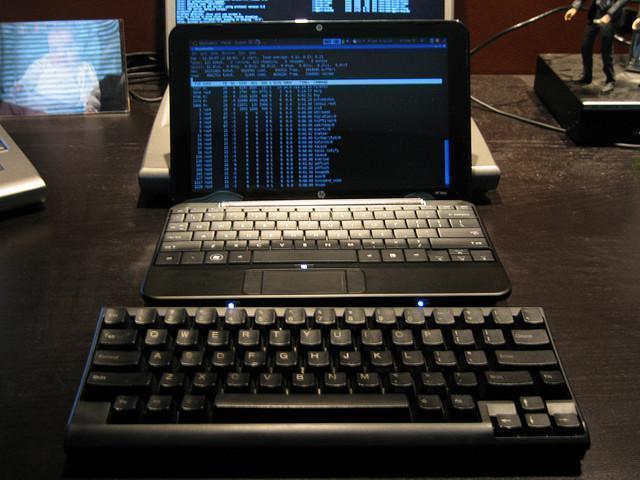How many keyboards are on the desk?
Give a very brief answer. 2. How many keyboards are there?
Give a very brief answer. 2. How many laptops are there?
Give a very brief answer. 2. 